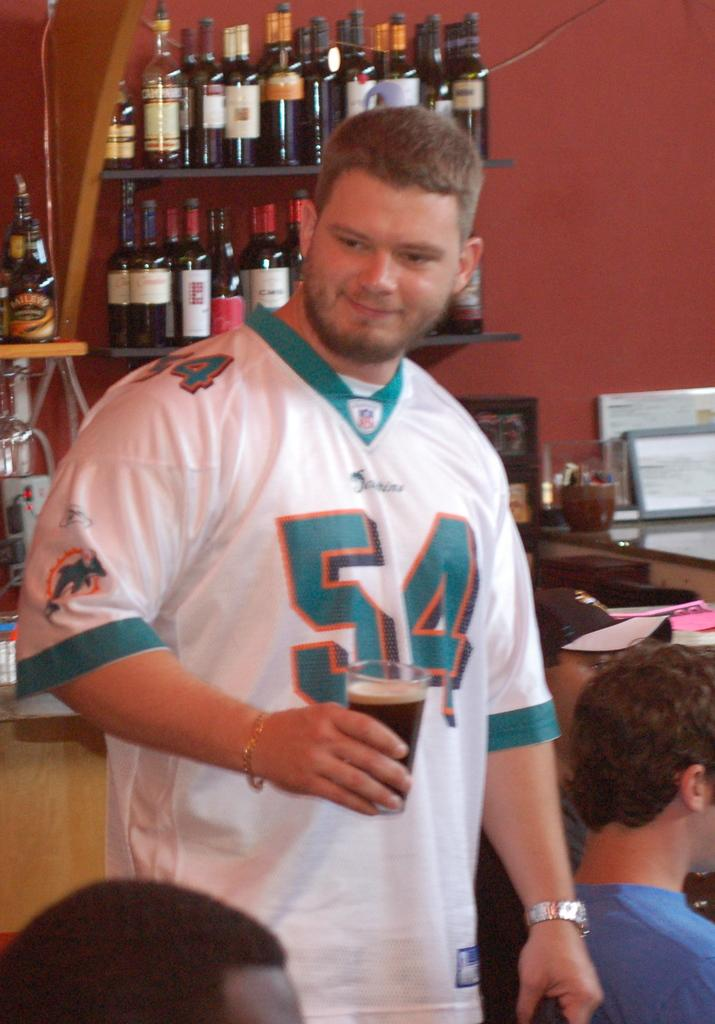<image>
Write a terse but informative summary of the picture. Man wearing a jersey with 54 on it holds a beer. 